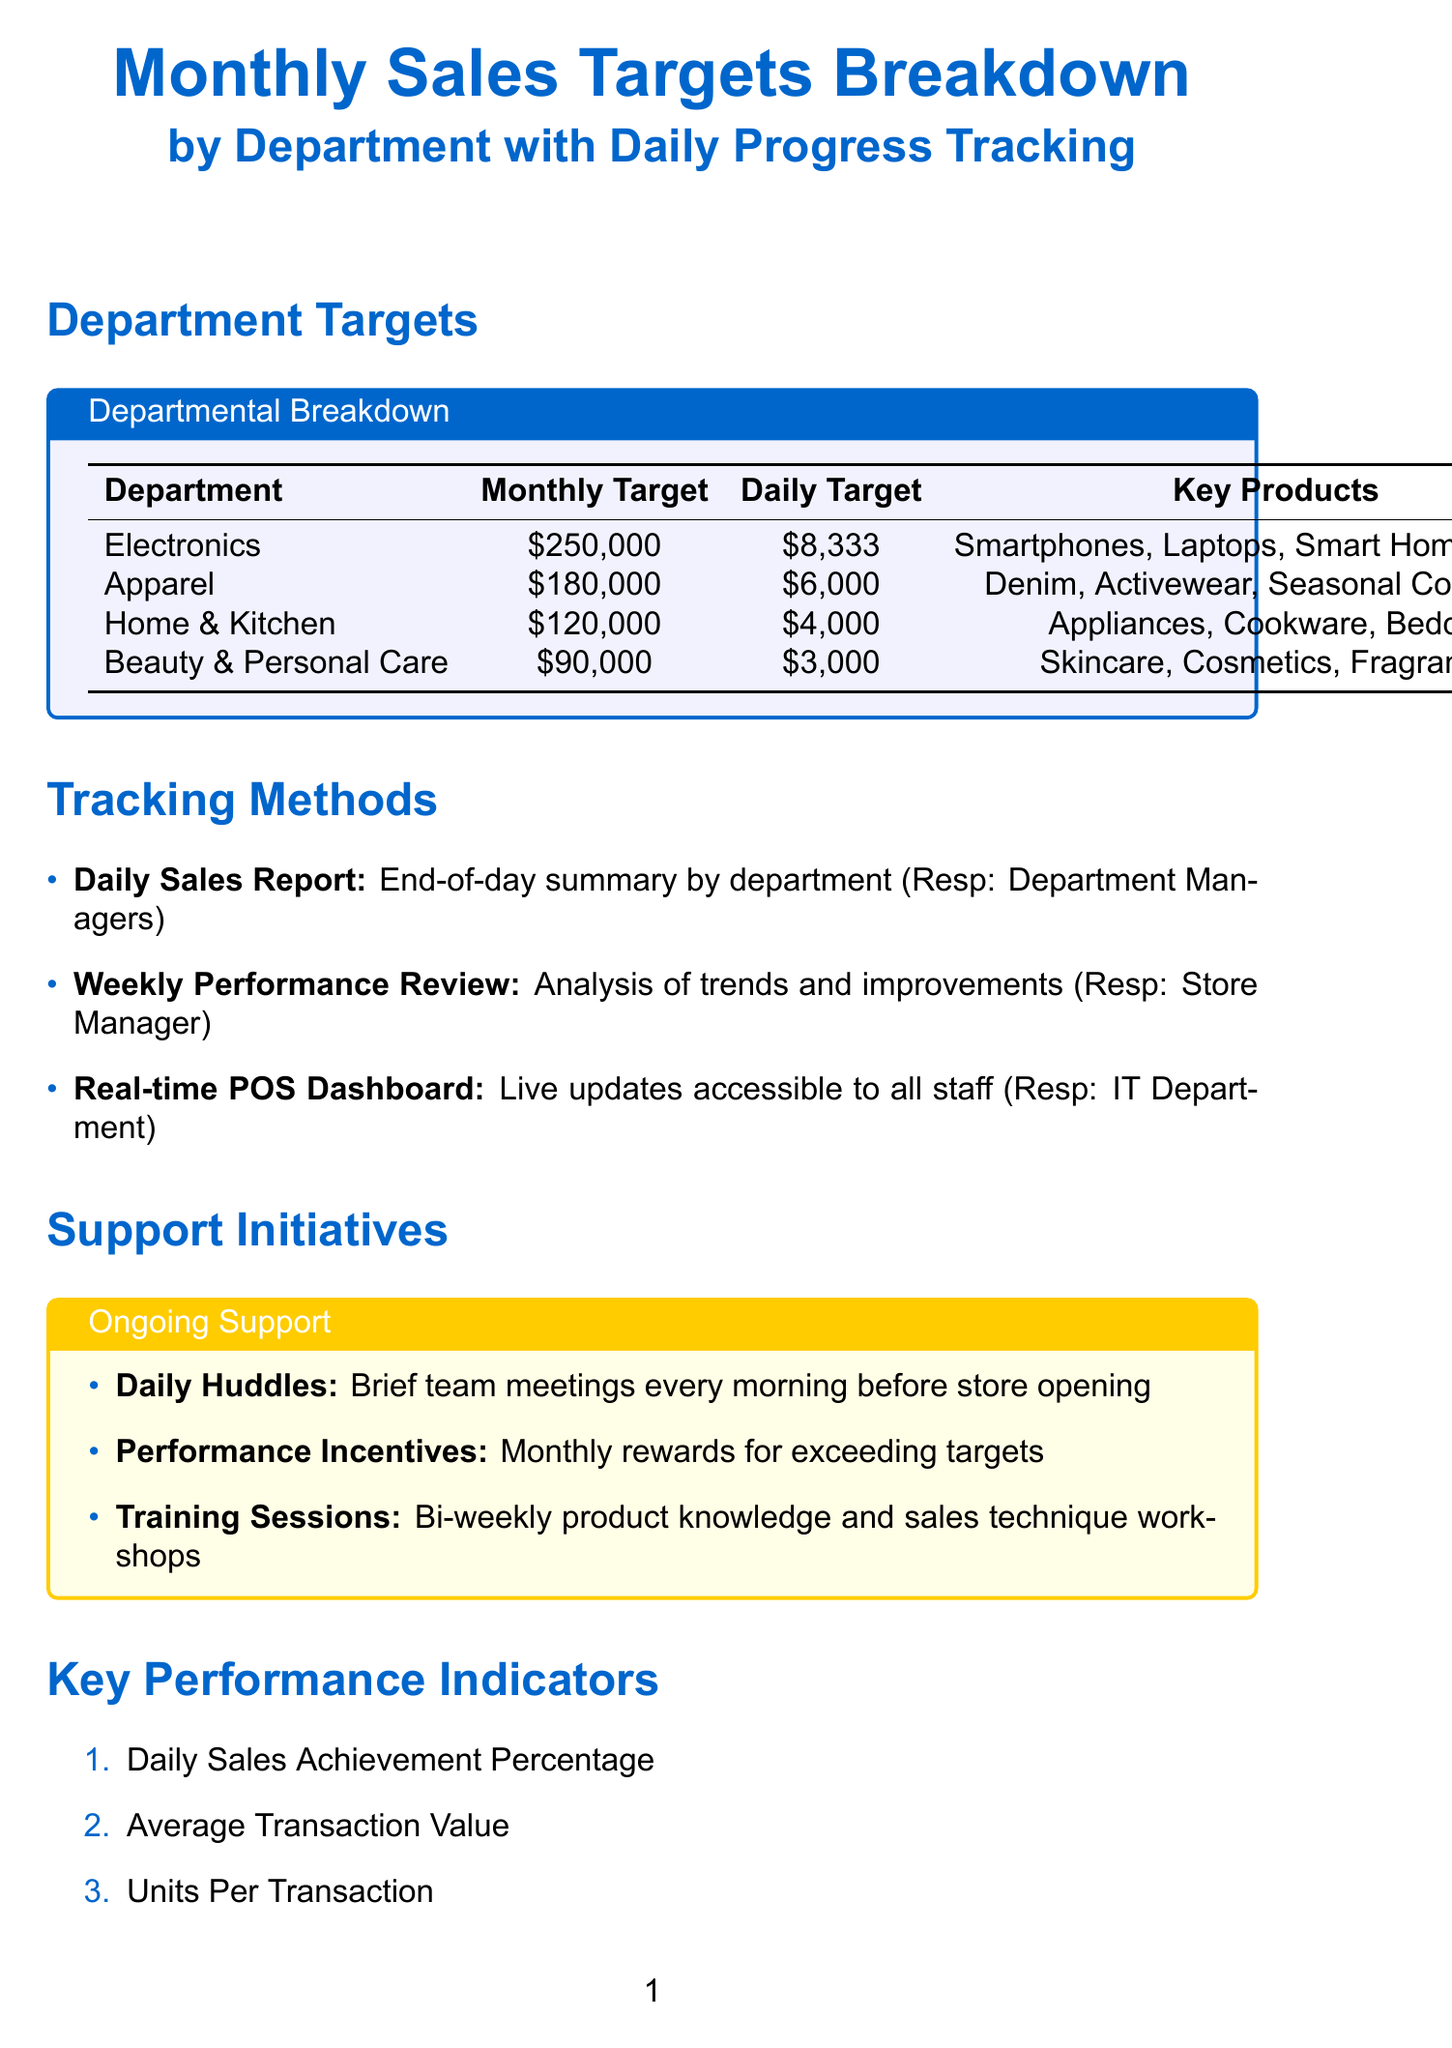What is the monthly target for Electronics? The monthly target for Electronics is specified in the document as $250,000.
Answer: $250,000 What is the daily target for Apparel? The document lists the daily target for Apparel as $6,000.
Answer: $6,000 Which department has the highest monthly sales target? By comparing the monthly targets for each department, Electronics has the highest target at $250,000.
Answer: Electronics What tracking method is responsible for live updates on sales figures? The document indicates that the Real-time POS Dashboard is responsible for live updates on sales figures.
Answer: Real-time POS Dashboard How often are the training sessions held? The document states that training sessions are conducted bi-weekly.
Answer: Bi-weekly What is the task due on the 1st day of each month? According to the document, the task due on the 1st day of each month is to update department-specific sales strategies.
Answer: Update department-specific sales strategies What is the incentive for the Sales Star of the Month? The document mentions several rewards, one of which is the employee spotlight in the company newsletter.
Answer: Employee spotlight in company newsletter Which department is responsible for analyzing competitor pricing? The document specifies that the Marketing Team is responsible for analyzing competitor pricing.
Answer: Marketing Team What is the average transaction value listed as a key performance indicator? The document includes Daily Sales Achievement Percentage, Average Transaction Value, Units Per Transaction, Conversion Rate, Customer Satisfaction Score as key performance indicators.
Answer: Daily Sales Achievement Percentage, Average Transaction Value, Units Per Transaction, Conversion Rate, Customer Satisfaction Score 